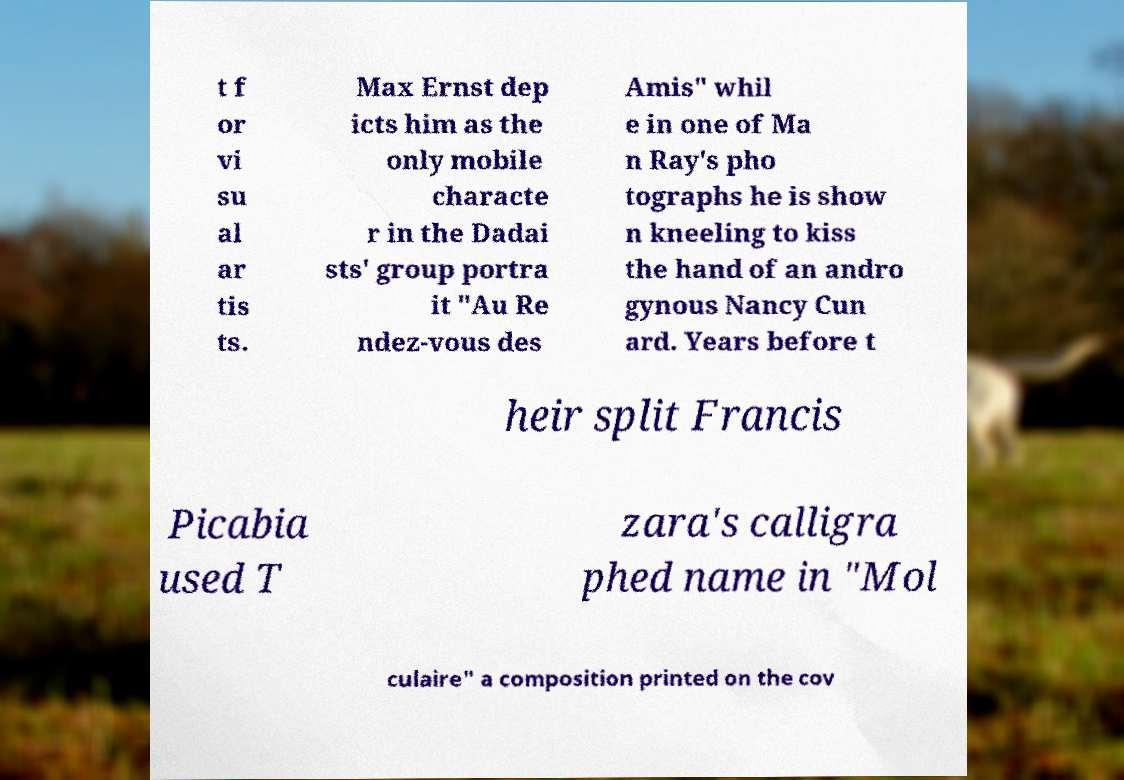What messages or text are displayed in this image? I need them in a readable, typed format. t f or vi su al ar tis ts. Max Ernst dep icts him as the only mobile characte r in the Dadai sts' group portra it "Au Re ndez-vous des Amis" whil e in one of Ma n Ray's pho tographs he is show n kneeling to kiss the hand of an andro gynous Nancy Cun ard. Years before t heir split Francis Picabia used T zara's calligra phed name in "Mol culaire" a composition printed on the cov 